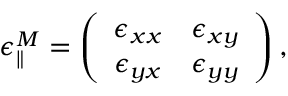Convert formula to latex. <formula><loc_0><loc_0><loc_500><loc_500>\epsilon _ { \| } ^ { M } = \left ( \begin{array} { c c } { \epsilon _ { x x } } & { \epsilon _ { x y } } \\ { \epsilon _ { y x } } & { \epsilon _ { y y } } \end{array} \right ) ,</formula> 